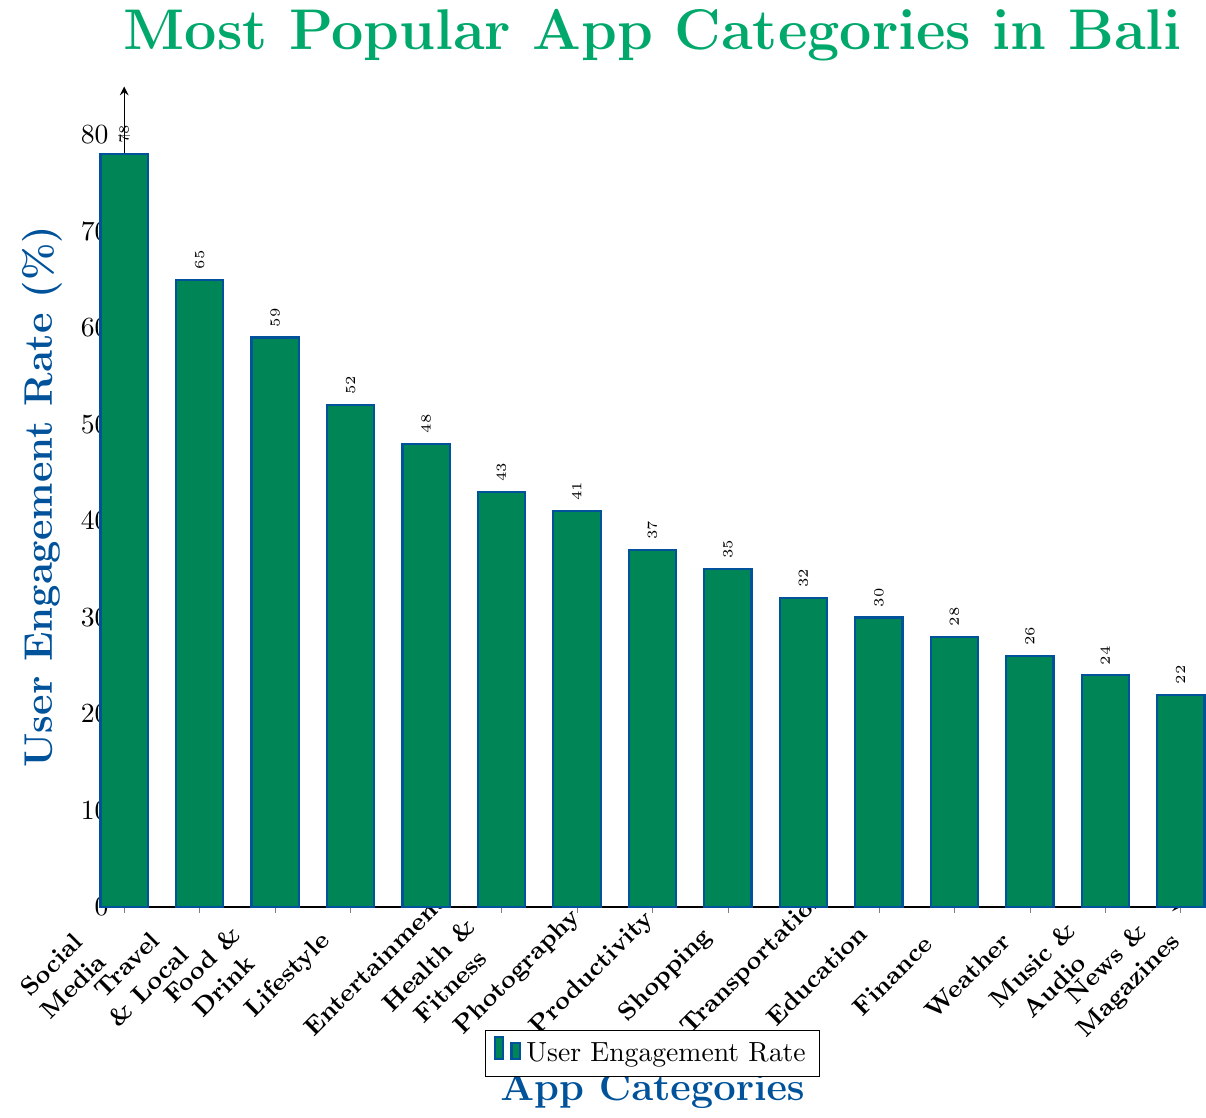What's the most popular app category in Bali based on user engagement rate? Look for the category with the highest bar in the figure. The tallest bar represents Social Media.
Answer: Social Media Which app category has a higher user engagement rate, Productivity or Shopping? Compare the heights of the bars for Productivity and Shopping. The bar for Productivity is higher than the bar for Shopping.
Answer: Productivity What is the difference in user engagement rate between the Entertainment and Finance categories? Subtract the user engagement rate of Finance (28%) from that of Entertainment (48%). The difference is 48% - 28% = 20%.
Answer: 20% What is the combined user engagement rate for Social Media, Travel & Local, and Food & Drink categories? Sum the user engagement rates for Social Media (78%), Travel & Local (65%), and Food & Drink (59%). The combined rate is 78% + 65% + 59% = 202%.
Answer: 202% Which categories have a user engagement rate lower than 30%? Identify the categories with bars that are shorter than the 30% mark. The categories are Education, Finance, Weather, Music & Audio, and News & Magazines.
Answer: Education, Finance, Weather, Music & Audio, News & Magazines What is the average user engagement rate of the top three app categories? Calculate the average of the user engagement rates for Social Media (78%), Travel & Local (65%), and Food & Drink (59%). The average rate is (78% + 65% + 59%) / 3 = 67.33%.
Answer: 67.33% How many categories have a user engagement rate above 50%? Count the number of bars that exceed the 50% mark. There are four categories: Social Media, Travel & Local, Food & Drink, and Lifestyle.
Answer: Four Are there more app categories with a user engagement rate above or below 40%? Count the categories above 40% (Social Media, Travel & Local, Food & Drink, Lifestyle, Entertainment, Health & Fitness, and Photography) and those below 40% (Productivity, Shopping, Transportation, Education, Finance, Weather, Music & Audio, News & Magazines). There are seven categories above 40% and eight below 40%.
Answer: Below What is the engagement rate range for the categories displayed? The range is found by subtracting the lowest engagement rate (News & Magazines, 22%) from the highest (Social Media, 78%). The range is 78% - 22% = 56%.
Answer: 56% How does the user engagement rate of Health & Fitness compare to that of Entertainment visually? Visually, the bar representing Health & Fitness (43%) is shorter than the bar for Entertainment (48%).
Answer: Health & Fitness is lower 